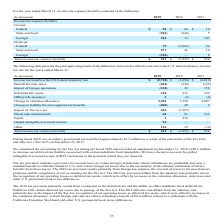According to Agilysys's financial document, What was the provisional tax benefit in 2018? approximately $3.3 million. The document states: "al 2018, we recorded a provisional tax benefit of approximately $3.3 million as a result of the enactment of the Tax Cuts and Jobs Act ("Tax Act") on ..." Also, What was the adjustment against the tax act in Q3 2019? According to the financial document, $0.2 million. The relevant text states: "and recorded an adjustment on December 31, 2018 of $0.2 million to increase our deferred tax liability associated with certain indefinite lived intangibles. We have..." Also, What are the years included in the table? The document contains multiple relevant values: 2019, 2018, 2017. From the document: "(In thousands) 2019 2018 2017 (In thousands) 2019 2018 2017 (In thousands) 2019 2018 2017..." Also, can you calculate: What was the increase / (decrease) in the benefit for state taxes from 2018 to 2019? Based on the calculation: -304 - (- 642), the result is 338 (in thousands). This is based on the information: "Benefit for state taxes (304) (642) (142) Benefit for state taxes (304) (642) (142)..." The key data points involved are: 304, 642. Also, can you calculate: What was the average indefinite life assets for 2017-2019? To answer this question, I need to perform calculations using the financial data. The calculation is: (130 + 335 + 102) / 3, which equals 189 (in thousands). This is based on the information: "Indefinite life assets 130 335 102 Indefinite life assets 130 335 102 Indefinite life assets 130 335 102..." The key data points involved are: 102, 130, 335. Also, can you calculate: What was the average Change in valuation allowance for 2017-2019? To answer this question, I need to perform calculations using the financial data. The calculation is: (3,302 + 3,328 + 4,007) / 3, which equals 3545.67 (in thousands). This is based on the information: "Change in valuation allowance 3,302 3,328 4,007 Change in valuation allowance 3,302 3,328 4,007 Change in valuation allowance 3,302 3,328 4,007..." The key data points involved are: 3,302, 3,328, 4,007. 